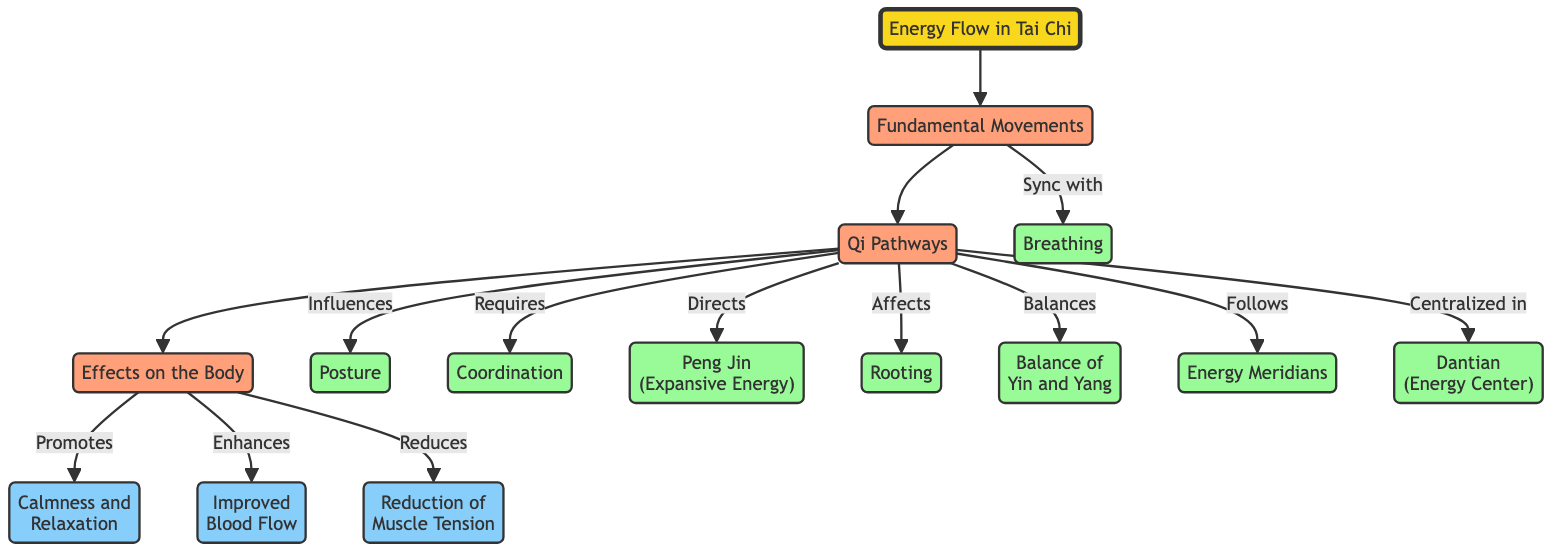What is represented at the root of the diagram? The root of the diagram is labeled "Energy Flow in Tai Chi," indicating the main theme of the diagram.
Answer: Energy Flow in Tai Chi How many fundamental movements are listed in the diagram? The diagram includes one node labeled "Fundamental Movements," indicating that it is a singular category without listing individual movements.
Answer: 1 Which pathway is centralized in the dantian? The diagram shows that "Qi Pathways" is centralized in the "Dantian" node, indicating the focus of energy flow.
Answer: Dantian What is one effect on the body promoted by Tai Chi movements? According to the diagram, "Calmness and Relaxation" is one of the effects identified as being promoted by Tai Chi movements.
Answer: Calmness and Relaxation What influences the posture according to the diagram? The diagram indicates that the "Qi Pathways" influence the "Posture," demonstrating the connection between energy flow and body alignment.
Answer: Qi Pathways How does "Qi Pathways" affect "Rooting"? The diagram states that "Qi Pathways" directly "Affects" "Rooting," illustrating a causal relationship in Tai Chi practice.
Answer: Affects What are the secondary categories related to Tai Chi movements? The diagram lists multiple secondary categories related to Tai Chi movements, specifically "Breathing," "Posture," "Coordination," "Peng Jin," "Rooting," "Balance of Yin and Yang," "Energy Meridians," and "Dantian," covering various aspects.
Answer: Breathing, Posture, Coordination, Peng Jin, Rooting, Balance of Yin and Yang, Energy Meridians, Dantian What is the relationship between body effects and muscle tension? The diagram shows that body effects lead to a "Reduction of Muscle Tension," highlighting a beneficial outcome of Tai Chi practice.
Answer: Reduction of Muscle Tension How many energy pathways are indicated in the diagram? The diagram does not specify a numerical value for energy pathways; rather, it includes one pathway labeled "Qi Pathways," representing the overall concept.
Answer: 1 